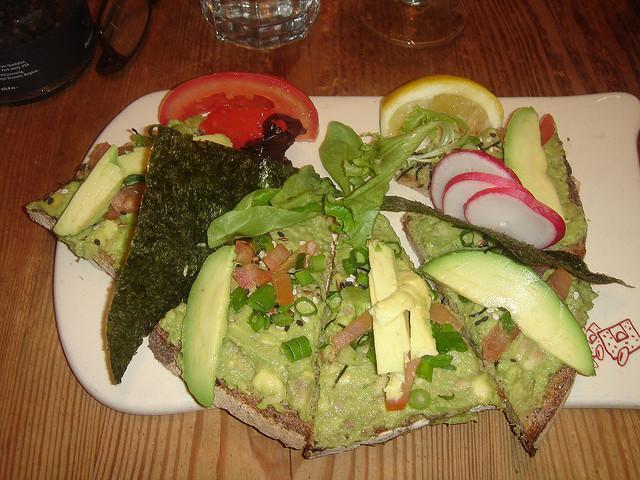How many pizzas are in the picture?
Give a very brief answer. 4. How many wine glasses are there?
Give a very brief answer. 1. How many giraffes are facing to the right?
Give a very brief answer. 0. 